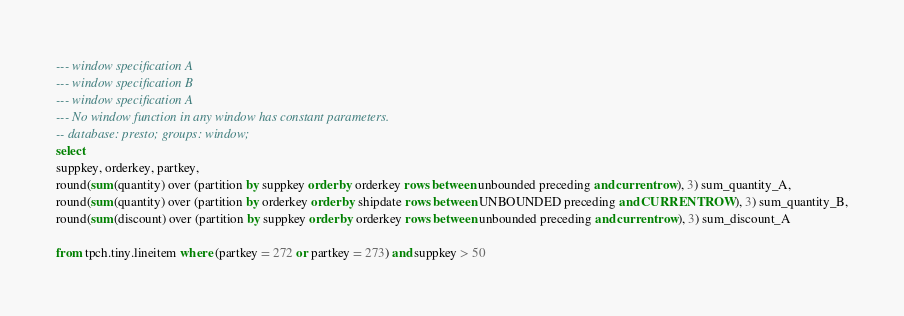<code> <loc_0><loc_0><loc_500><loc_500><_SQL_>--- window specification A
--- window specification B
--- window specification A
--- No window function in any window has constant parameters.
-- database: presto; groups: window;
select
suppkey, orderkey, partkey,
round(sum(quantity) over (partition by suppkey order by orderkey rows between unbounded preceding and current row), 3) sum_quantity_A,
round(sum(quantity) over (partition by orderkey order by shipdate rows between UNBOUNDED preceding and CURRENT ROW), 3) sum_quantity_B,
round(sum(discount) over (partition by suppkey order by orderkey rows between unbounded preceding and current row), 3) sum_discount_A

from tpch.tiny.lineitem where (partkey = 272 or partkey = 273) and suppkey > 50
</code> 